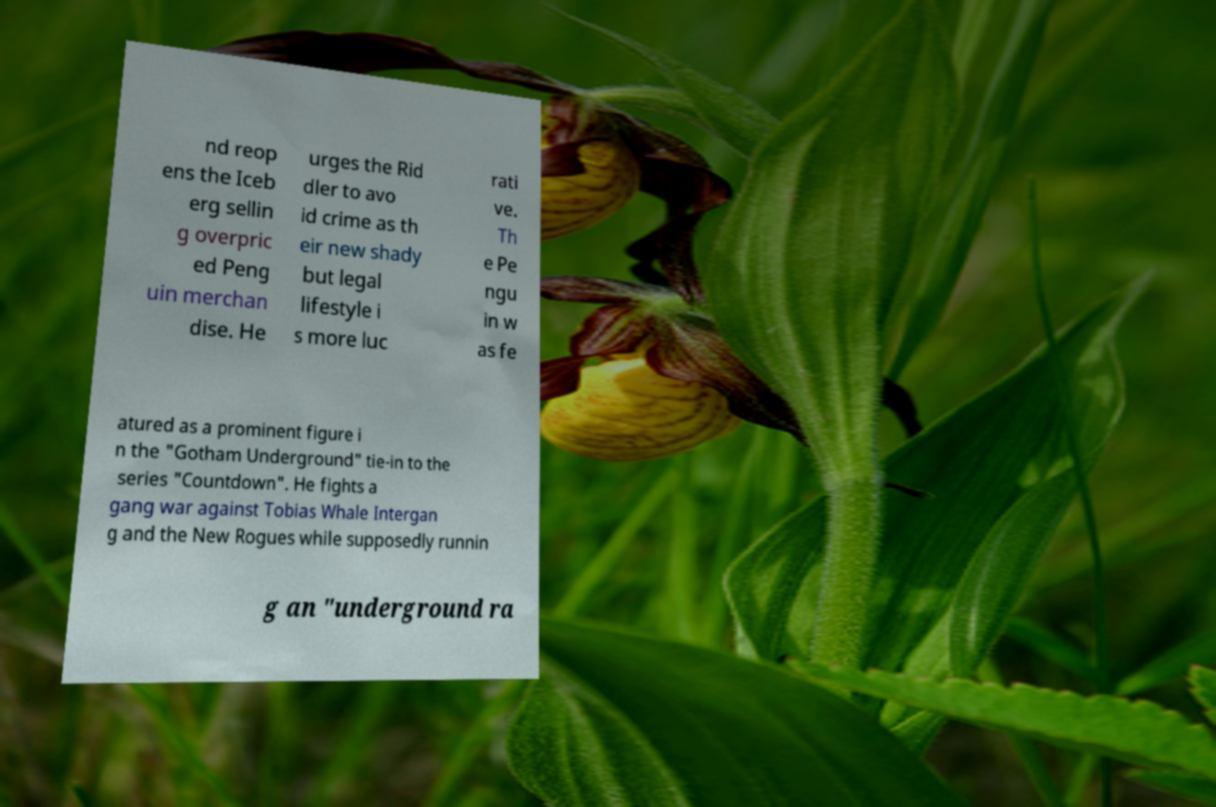I need the written content from this picture converted into text. Can you do that? nd reop ens the Iceb erg sellin g overpric ed Peng uin merchan dise. He urges the Rid dler to avo id crime as th eir new shady but legal lifestyle i s more luc rati ve. Th e Pe ngu in w as fe atured as a prominent figure i n the "Gotham Underground" tie-in to the series "Countdown". He fights a gang war against Tobias Whale Intergan g and the New Rogues while supposedly runnin g an "underground ra 